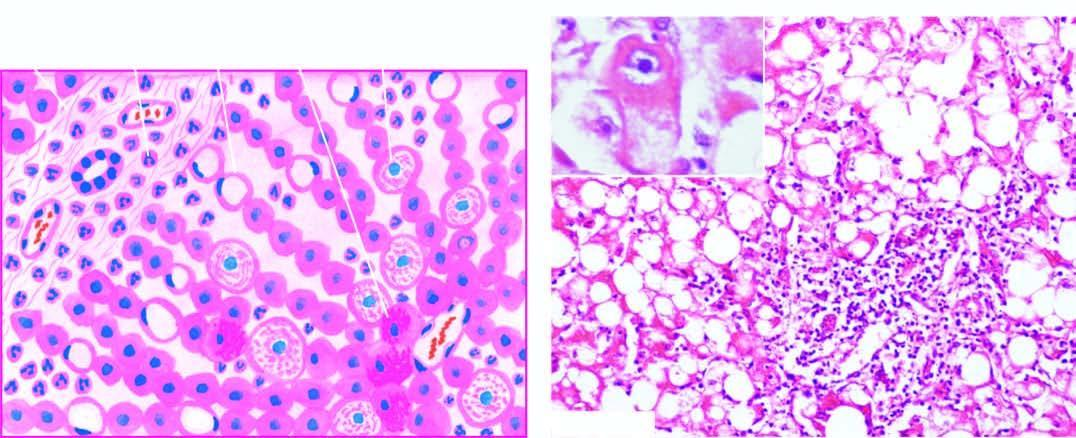what show ballooning degeneration and necrosis with some containing mallory 's hyalin inbox?
Answer the question using a single word or phrase. Liver cells 